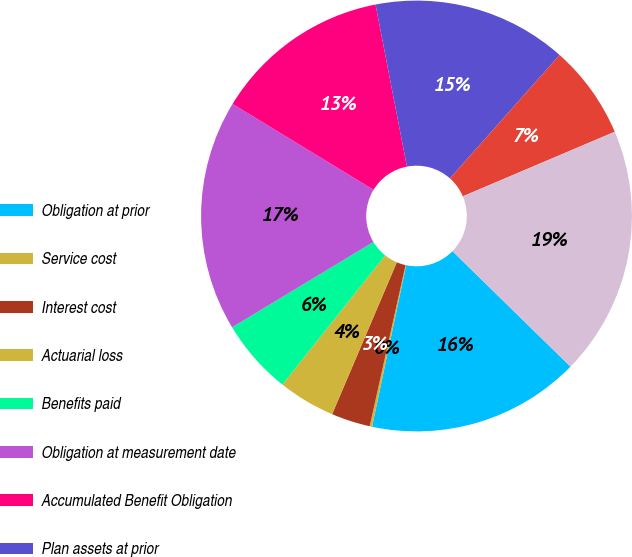<chart> <loc_0><loc_0><loc_500><loc_500><pie_chart><fcel>Obligation at prior<fcel>Service cost<fcel>Interest cost<fcel>Actuarial loss<fcel>Benefits paid<fcel>Obligation at measurement date<fcel>Accumulated Benefit Obligation<fcel>Plan assets at prior<fcel>Actual return on plan assets<fcel>Plan assets at measurement<nl><fcel>15.98%<fcel>0.18%<fcel>2.92%<fcel>4.29%<fcel>5.66%<fcel>17.35%<fcel>13.24%<fcel>14.61%<fcel>7.04%<fcel>18.72%<nl></chart> 